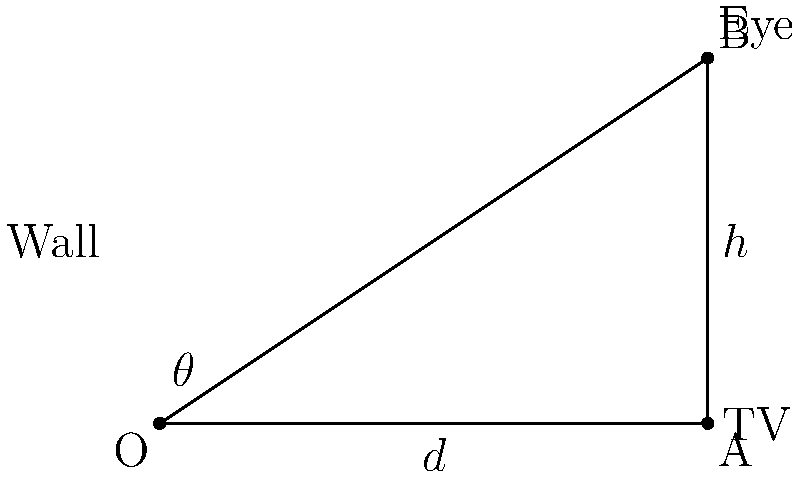You want to mount your new TV on the wall of your apartment for optimal viewing. The center of the TV will be at a height $h = 4$ feet above eye level, and you'll be sitting at a distance $d = 6$ feet from the wall. What is the optimal viewing angle $\theta$ (in degrees) for the TV, assuming you want to look straight at the center of the screen? Let's approach this step-by-step:

1) First, we need to identify the trigonometric relationship in this scenario. We have a right triangle where:
   - The adjacent side to angle $\theta$ is the distance $d = 6$ feet
   - The opposite side to angle $\theta$ is the height difference $h = 4$ feet
   - We need to find the angle $\theta$

2) In this case, we can use the tangent function, which is defined as the ratio of the opposite side to the adjacent side:

   $$\tan \theta = \frac{\text{opposite}}{\text{adjacent}} = \frac{h}{d}$$

3) Substituting our known values:

   $$\tan \theta = \frac{4}{6} = \frac{2}{3}$$

4) To find $\theta$, we need to take the inverse tangent (arctan or $\tan^{-1}$) of both sides:

   $$\theta = \tan^{-1}(\frac{2}{3})$$

5) Using a calculator or trigonometric tables, we can evaluate this:

   $$\theta \approx 33.69^\circ$$

6) Rounding to the nearest degree:

   $$\theta \approx 34^\circ$$

Therefore, the optimal viewing angle for your wall-mounted TV is approximately 34 degrees.
Answer: 34° 